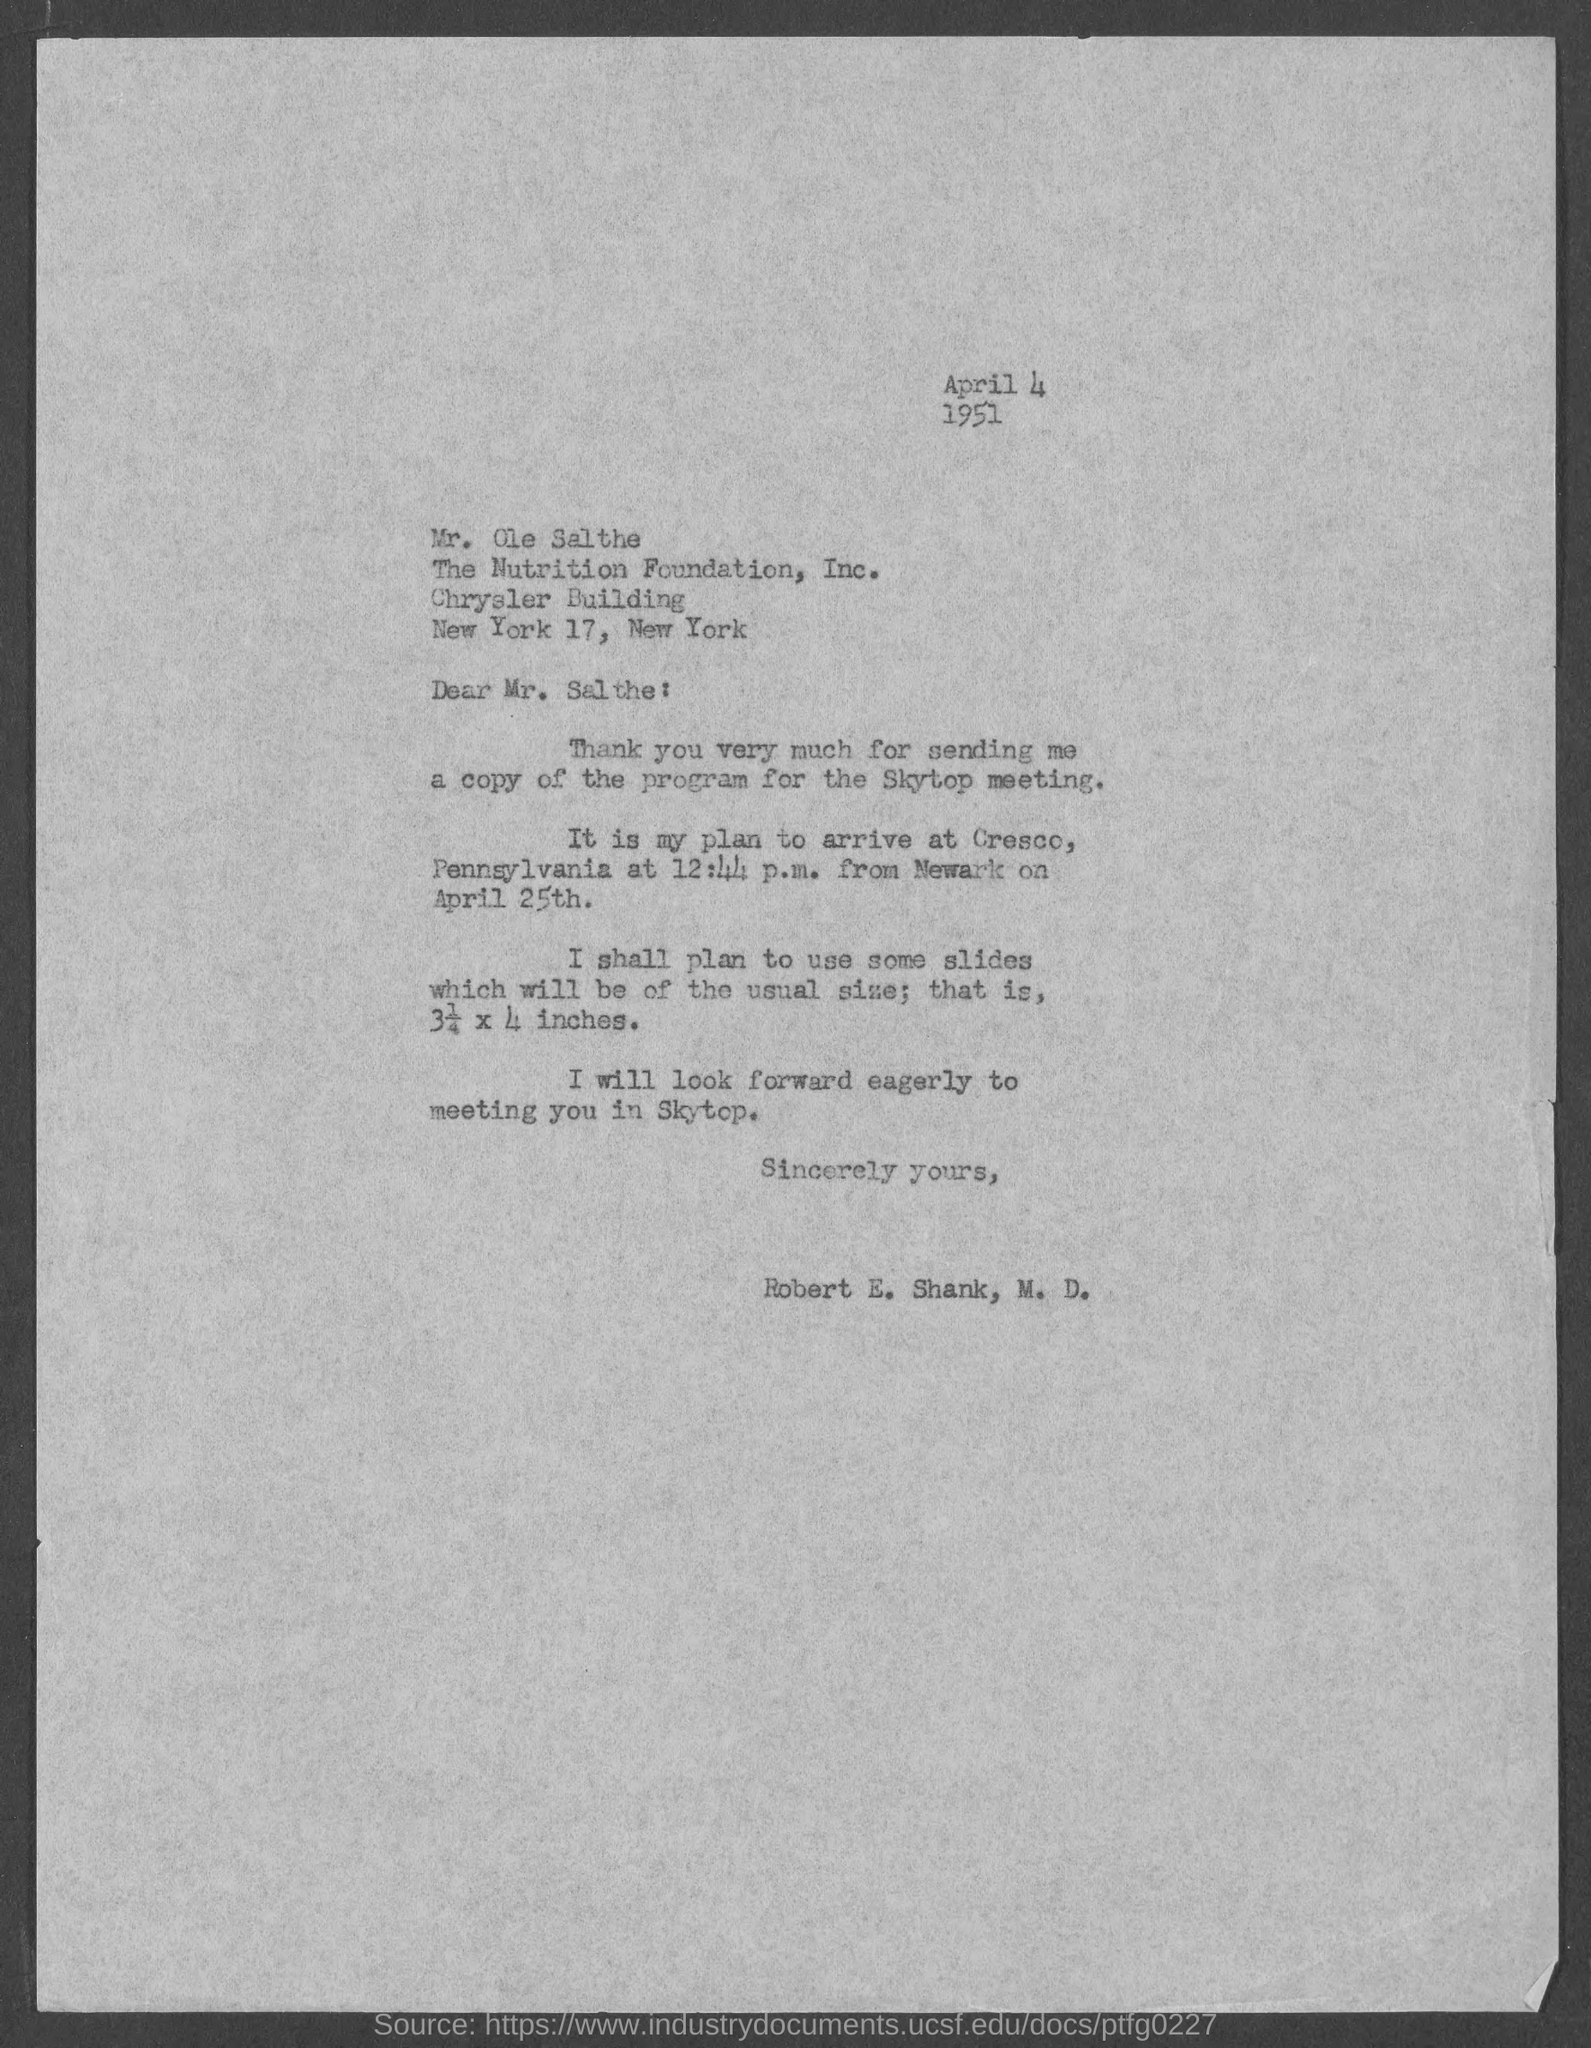What is the date mentioned in the top of the document ?
Provide a succinct answer. April 4 1951. What time is written in the Letter ?
Your answer should be very brief. 12:44 p.m. 